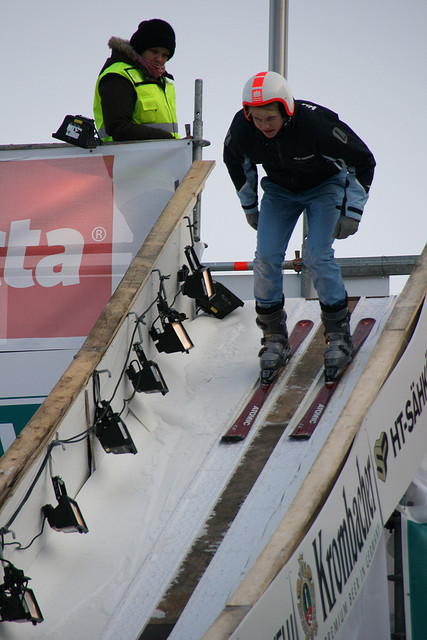Identify the text contained in this image. ta R Krombacber HT-SAH 